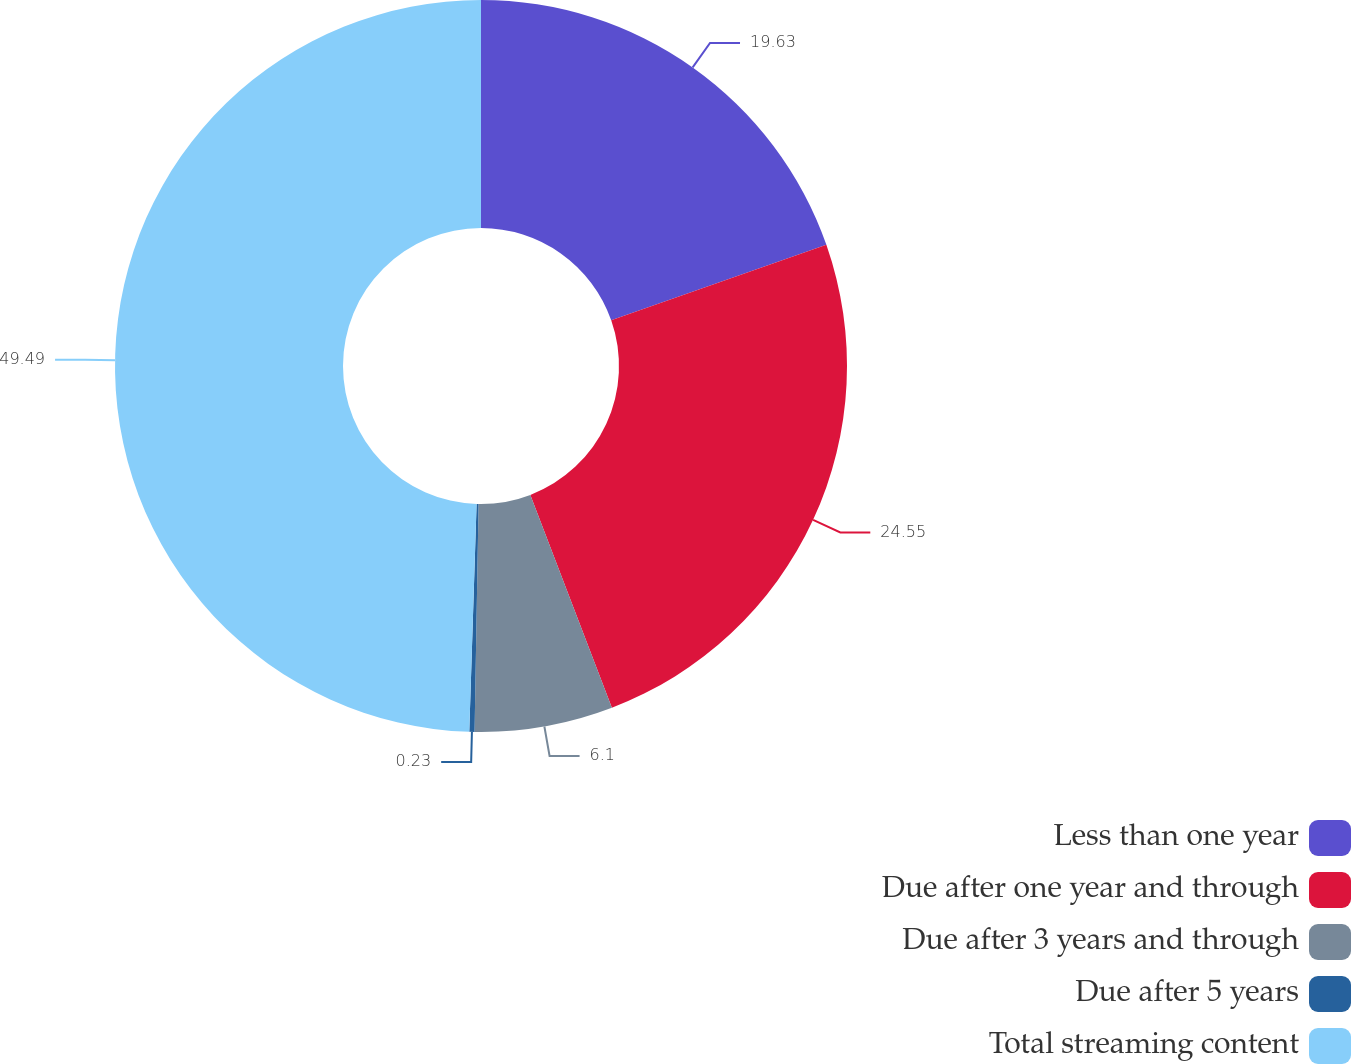<chart> <loc_0><loc_0><loc_500><loc_500><pie_chart><fcel>Less than one year<fcel>Due after one year and through<fcel>Due after 3 years and through<fcel>Due after 5 years<fcel>Total streaming content<nl><fcel>19.63%<fcel>24.55%<fcel>6.1%<fcel>0.23%<fcel>49.49%<nl></chart> 